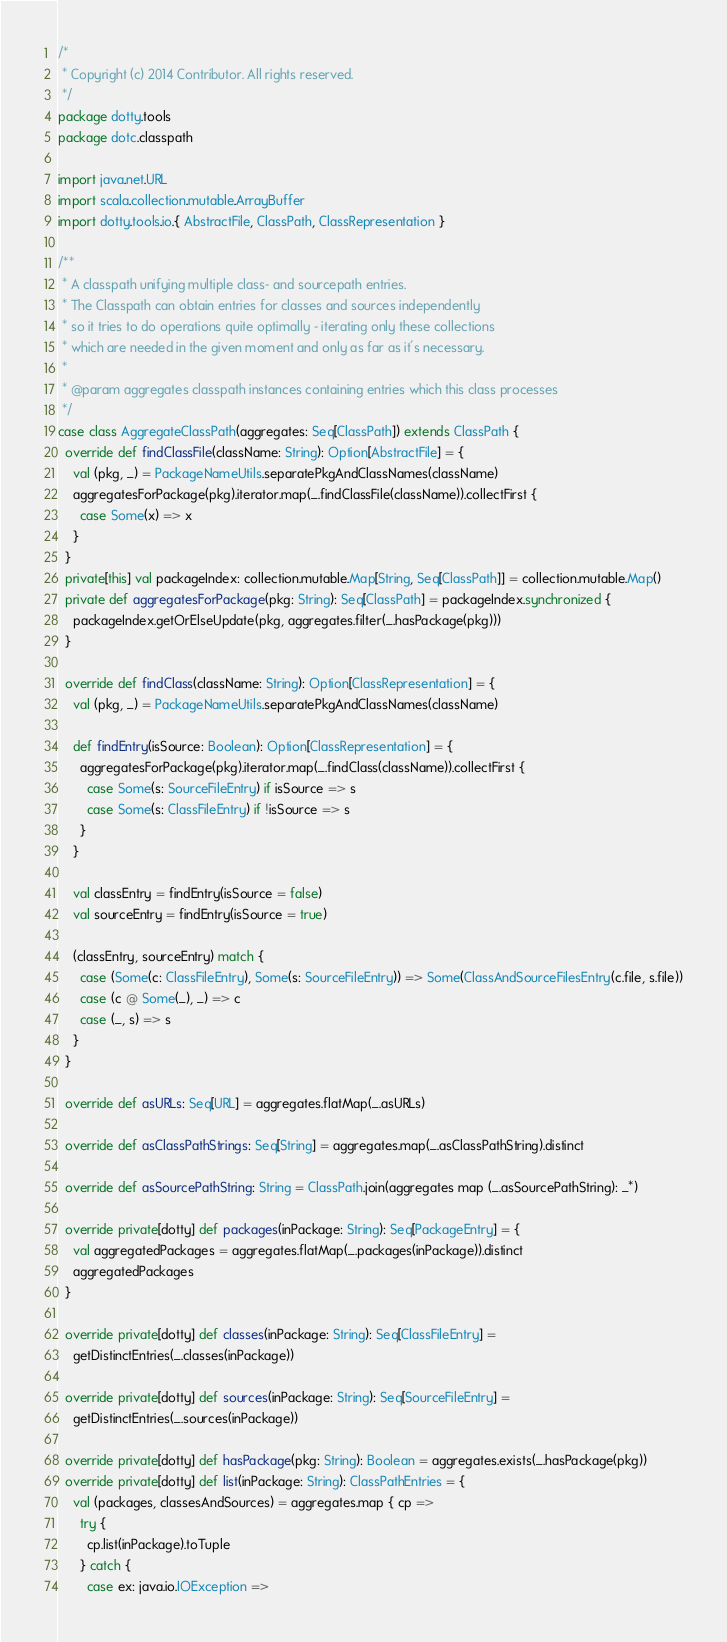<code> <loc_0><loc_0><loc_500><loc_500><_Scala_>/*
 * Copyright (c) 2014 Contributor. All rights reserved.
 */
package dotty.tools
package dotc.classpath

import java.net.URL
import scala.collection.mutable.ArrayBuffer
import dotty.tools.io.{ AbstractFile, ClassPath, ClassRepresentation }

/**
 * A classpath unifying multiple class- and sourcepath entries.
 * The Classpath can obtain entries for classes and sources independently
 * so it tries to do operations quite optimally - iterating only these collections
 * which are needed in the given moment and only as far as it's necessary.
 *
 * @param aggregates classpath instances containing entries which this class processes
 */
case class AggregateClassPath(aggregates: Seq[ClassPath]) extends ClassPath {
  override def findClassFile(className: String): Option[AbstractFile] = {
    val (pkg, _) = PackageNameUtils.separatePkgAndClassNames(className)
    aggregatesForPackage(pkg).iterator.map(_.findClassFile(className)).collectFirst {
      case Some(x) => x
    }
  }
  private[this] val packageIndex: collection.mutable.Map[String, Seq[ClassPath]] = collection.mutable.Map()
  private def aggregatesForPackage(pkg: String): Seq[ClassPath] = packageIndex.synchronized {
    packageIndex.getOrElseUpdate(pkg, aggregates.filter(_.hasPackage(pkg)))
  }

  override def findClass(className: String): Option[ClassRepresentation] = {
    val (pkg, _) = PackageNameUtils.separatePkgAndClassNames(className)

    def findEntry(isSource: Boolean): Option[ClassRepresentation] = {
      aggregatesForPackage(pkg).iterator.map(_.findClass(className)).collectFirst {
        case Some(s: SourceFileEntry) if isSource => s
        case Some(s: ClassFileEntry) if !isSource => s
      }
    }

    val classEntry = findEntry(isSource = false)
    val sourceEntry = findEntry(isSource = true)

    (classEntry, sourceEntry) match {
      case (Some(c: ClassFileEntry), Some(s: SourceFileEntry)) => Some(ClassAndSourceFilesEntry(c.file, s.file))
      case (c @ Some(_), _) => c
      case (_, s) => s
    }
  }

  override def asURLs: Seq[URL] = aggregates.flatMap(_.asURLs)

  override def asClassPathStrings: Seq[String] = aggregates.map(_.asClassPathString).distinct

  override def asSourcePathString: String = ClassPath.join(aggregates map (_.asSourcePathString): _*)

  override private[dotty] def packages(inPackage: String): Seq[PackageEntry] = {
    val aggregatedPackages = aggregates.flatMap(_.packages(inPackage)).distinct
    aggregatedPackages
  }

  override private[dotty] def classes(inPackage: String): Seq[ClassFileEntry] =
    getDistinctEntries(_.classes(inPackage))

  override private[dotty] def sources(inPackage: String): Seq[SourceFileEntry] =
    getDistinctEntries(_.sources(inPackage))

  override private[dotty] def hasPackage(pkg: String): Boolean = aggregates.exists(_.hasPackage(pkg))
  override private[dotty] def list(inPackage: String): ClassPathEntries = {
    val (packages, classesAndSources) = aggregates.map { cp =>
      try {
        cp.list(inPackage).toTuple
      } catch {
        case ex: java.io.IOException =></code> 